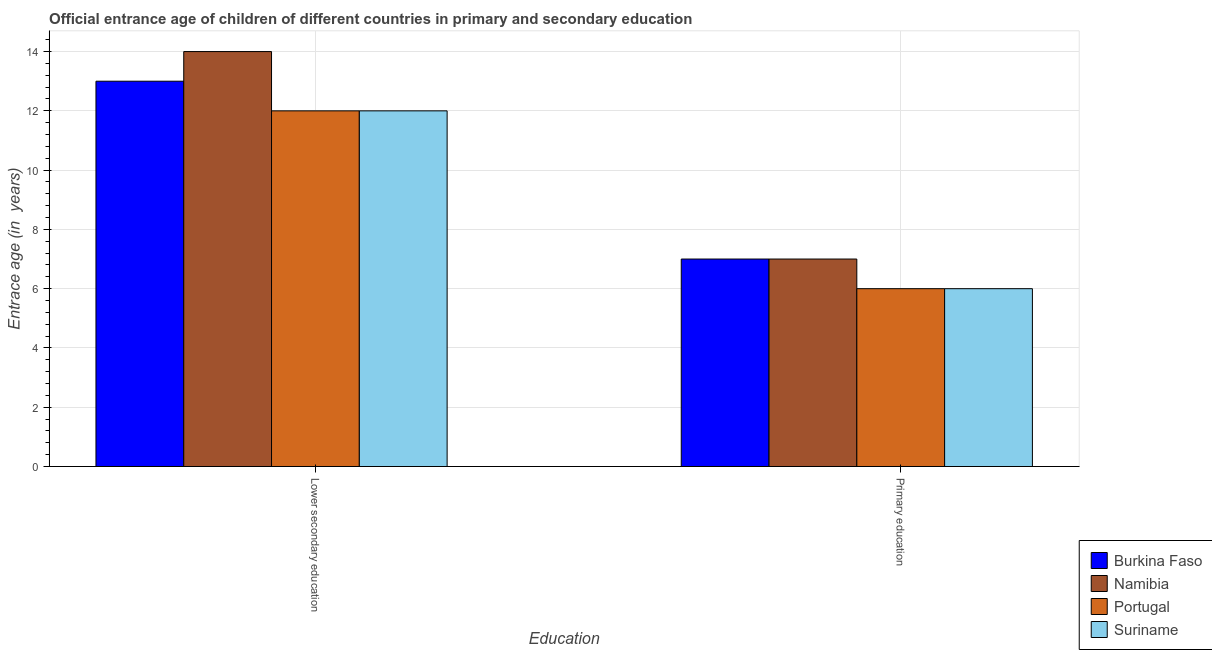How many different coloured bars are there?
Make the answer very short. 4. How many groups of bars are there?
Provide a short and direct response. 2. Are the number of bars per tick equal to the number of legend labels?
Your answer should be compact. Yes. Across all countries, what is the maximum entrance age of children in lower secondary education?
Offer a terse response. 14. Across all countries, what is the minimum entrance age of children in lower secondary education?
Ensure brevity in your answer.  12. In which country was the entrance age of children in lower secondary education maximum?
Provide a succinct answer. Namibia. In which country was the entrance age of children in lower secondary education minimum?
Provide a short and direct response. Portugal. What is the total entrance age of chiildren in primary education in the graph?
Your answer should be compact. 26. What is the difference between the entrance age of children in lower secondary education in Namibia and that in Portugal?
Offer a very short reply. 2. What is the average entrance age of chiildren in primary education per country?
Make the answer very short. 6.5. What is the difference between the entrance age of chiildren in primary education and entrance age of children in lower secondary education in Suriname?
Your answer should be compact. -6. In how many countries, is the entrance age of chiildren in primary education greater than 4 years?
Offer a terse response. 4. What is the ratio of the entrance age of chiildren in primary education in Suriname to that in Burkina Faso?
Provide a succinct answer. 0.86. Is the entrance age of chiildren in primary education in Suriname less than that in Burkina Faso?
Offer a terse response. Yes. What does the 4th bar from the left in Lower secondary education represents?
Make the answer very short. Suriname. How many countries are there in the graph?
Provide a short and direct response. 4. What is the difference between two consecutive major ticks on the Y-axis?
Provide a succinct answer. 2. Does the graph contain any zero values?
Provide a succinct answer. No. How many legend labels are there?
Offer a very short reply. 4. What is the title of the graph?
Your response must be concise. Official entrance age of children of different countries in primary and secondary education. Does "Indonesia" appear as one of the legend labels in the graph?
Make the answer very short. No. What is the label or title of the X-axis?
Keep it short and to the point. Education. What is the label or title of the Y-axis?
Ensure brevity in your answer.  Entrace age (in  years). What is the Entrace age (in  years) in Burkina Faso in Lower secondary education?
Make the answer very short. 13. What is the Entrace age (in  years) of Portugal in Lower secondary education?
Offer a terse response. 12. What is the Entrace age (in  years) of Namibia in Primary education?
Your answer should be very brief. 7. What is the Entrace age (in  years) of Portugal in Primary education?
Offer a very short reply. 6. Across all Education, what is the maximum Entrace age (in  years) in Burkina Faso?
Make the answer very short. 13. Across all Education, what is the maximum Entrace age (in  years) of Namibia?
Make the answer very short. 14. Across all Education, what is the maximum Entrace age (in  years) in Portugal?
Provide a succinct answer. 12. Across all Education, what is the maximum Entrace age (in  years) in Suriname?
Offer a terse response. 12. What is the total Entrace age (in  years) in Namibia in the graph?
Make the answer very short. 21. What is the total Entrace age (in  years) of Portugal in the graph?
Provide a short and direct response. 18. What is the difference between the Entrace age (in  years) in Burkina Faso in Lower secondary education and that in Primary education?
Your answer should be compact. 6. What is the difference between the Entrace age (in  years) in Burkina Faso in Lower secondary education and the Entrace age (in  years) in Namibia in Primary education?
Make the answer very short. 6. What is the difference between the Entrace age (in  years) in Burkina Faso in Lower secondary education and the Entrace age (in  years) in Portugal in Primary education?
Provide a succinct answer. 7. What is the difference between the Entrace age (in  years) of Namibia in Lower secondary education and the Entrace age (in  years) of Portugal in Primary education?
Your answer should be compact. 8. What is the difference between the Entrace age (in  years) of Namibia in Lower secondary education and the Entrace age (in  years) of Suriname in Primary education?
Give a very brief answer. 8. What is the difference between the Entrace age (in  years) of Portugal in Lower secondary education and the Entrace age (in  years) of Suriname in Primary education?
Make the answer very short. 6. What is the average Entrace age (in  years) of Burkina Faso per Education?
Keep it short and to the point. 10. What is the average Entrace age (in  years) in Portugal per Education?
Provide a short and direct response. 9. What is the difference between the Entrace age (in  years) in Burkina Faso and Entrace age (in  years) in Namibia in Lower secondary education?
Offer a very short reply. -1. What is the difference between the Entrace age (in  years) of Namibia and Entrace age (in  years) of Suriname in Lower secondary education?
Keep it short and to the point. 2. What is the difference between the Entrace age (in  years) in Namibia and Entrace age (in  years) in Portugal in Primary education?
Your response must be concise. 1. What is the ratio of the Entrace age (in  years) in Burkina Faso in Lower secondary education to that in Primary education?
Provide a succinct answer. 1.86. What is the ratio of the Entrace age (in  years) in Namibia in Lower secondary education to that in Primary education?
Keep it short and to the point. 2. What is the ratio of the Entrace age (in  years) of Suriname in Lower secondary education to that in Primary education?
Ensure brevity in your answer.  2. What is the difference between the highest and the second highest Entrace age (in  years) of Namibia?
Your response must be concise. 7. What is the difference between the highest and the second highest Entrace age (in  years) in Portugal?
Offer a very short reply. 6. What is the difference between the highest and the lowest Entrace age (in  years) of Burkina Faso?
Keep it short and to the point. 6. What is the difference between the highest and the lowest Entrace age (in  years) of Namibia?
Offer a terse response. 7. What is the difference between the highest and the lowest Entrace age (in  years) in Suriname?
Your answer should be compact. 6. 